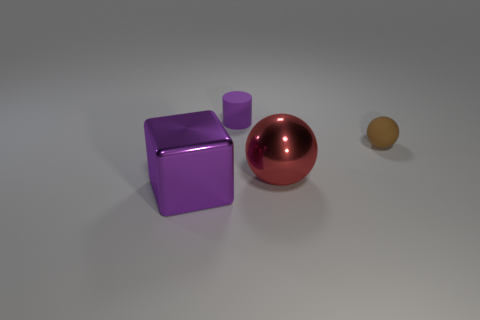Is there anything else that is the same shape as the small purple matte thing?
Provide a succinct answer. No. Are there any matte things that have the same color as the metal cube?
Provide a succinct answer. Yes. Are there fewer small brown things than big red matte cylinders?
Make the answer very short. No. How many objects are either large matte blocks or purple objects that are behind the metallic block?
Ensure brevity in your answer.  1. Are there any large purple things that have the same material as the big red sphere?
Make the answer very short. Yes. What material is the purple object that is the same size as the brown ball?
Provide a succinct answer. Rubber. There is a object that is in front of the large shiny thing behind the big shiny cube; what is it made of?
Keep it short and to the point. Metal. Do the metallic object that is to the right of the tiny rubber cylinder and the tiny brown object have the same shape?
Make the answer very short. Yes. What color is the ball that is the same material as the purple cube?
Offer a very short reply. Red. What is the material of the object that is in front of the big red metal thing?
Your answer should be very brief. Metal. 